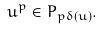<formula> <loc_0><loc_0><loc_500><loc_500>u ^ { p } \in P _ { p \delta ( u ) } .</formula> 